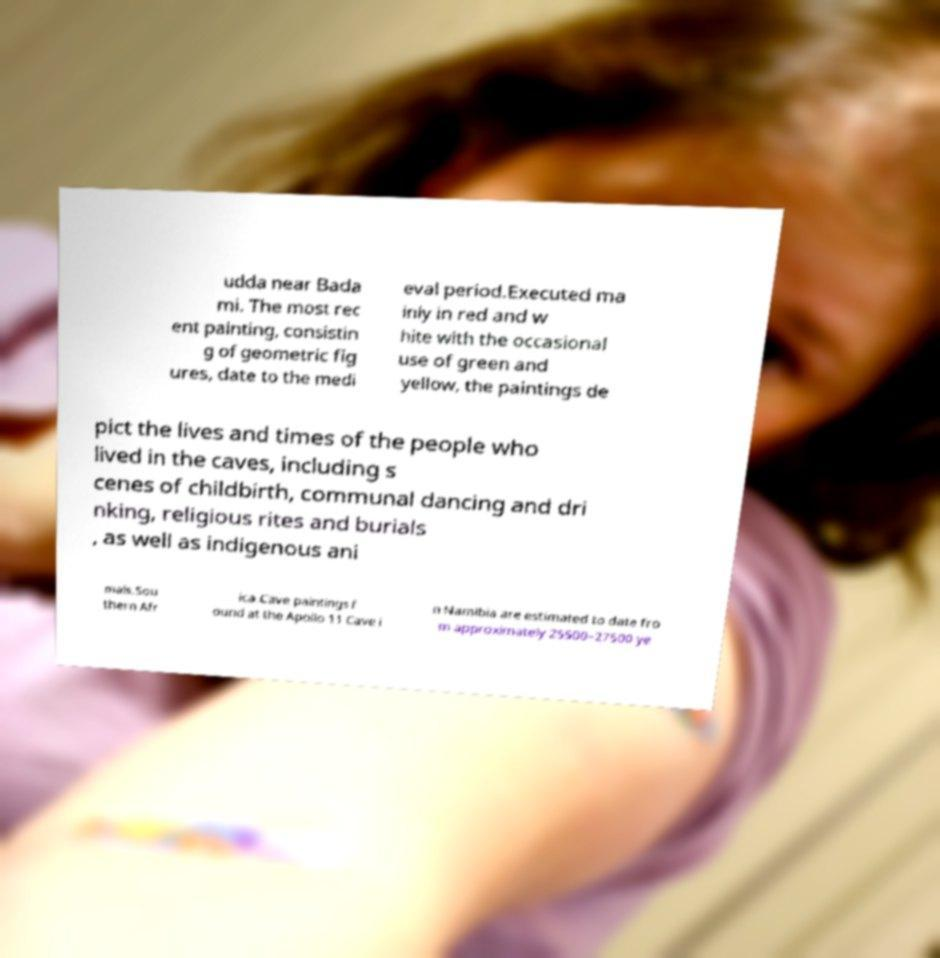Could you extract and type out the text from this image? udda near Bada mi. The most rec ent painting, consistin g of geometric fig ures, date to the medi eval period.Executed ma inly in red and w hite with the occasional use of green and yellow, the paintings de pict the lives and times of the people who lived in the caves, including s cenes of childbirth, communal dancing and dri nking, religious rites and burials , as well as indigenous ani mals.Sou thern Afr ica.Cave paintings f ound at the Apollo 11 Cave i n Namibia are estimated to date fro m approximately 25500–27500 ye 